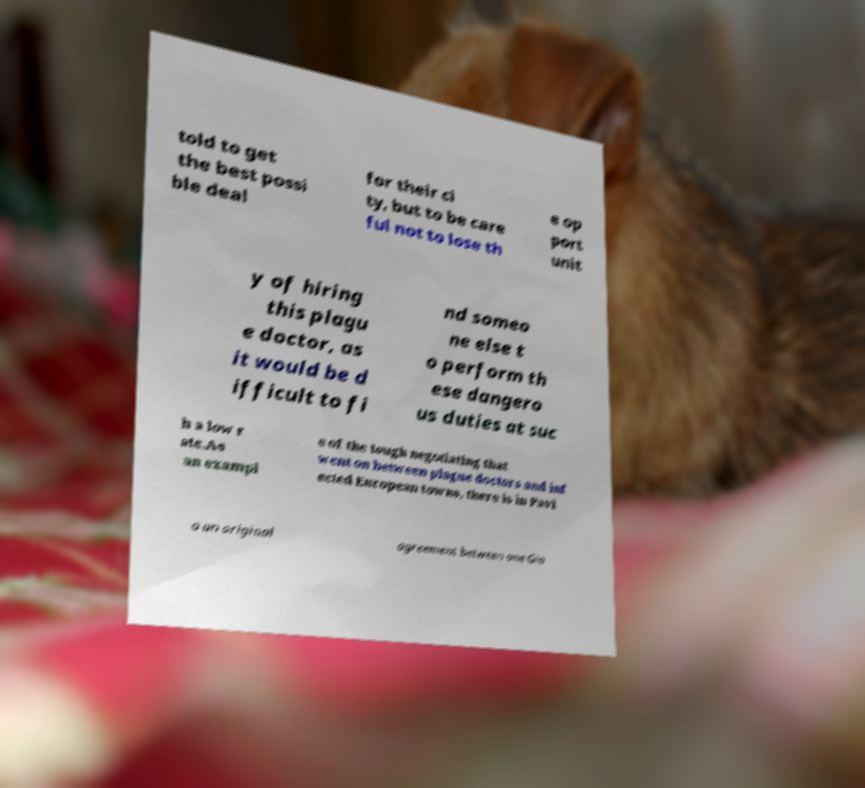Could you assist in decoding the text presented in this image and type it out clearly? told to get the best possi ble deal for their ci ty, but to be care ful not to lose th e op port unit y of hiring this plagu e doctor, as it would be d ifficult to fi nd someo ne else t o perform th ese dangero us duties at suc h a low r ate.As an exampl e of the tough negotiating that went on between plague doctors and inf ected European towns, there is in Pavi a an original agreement between one Gio 